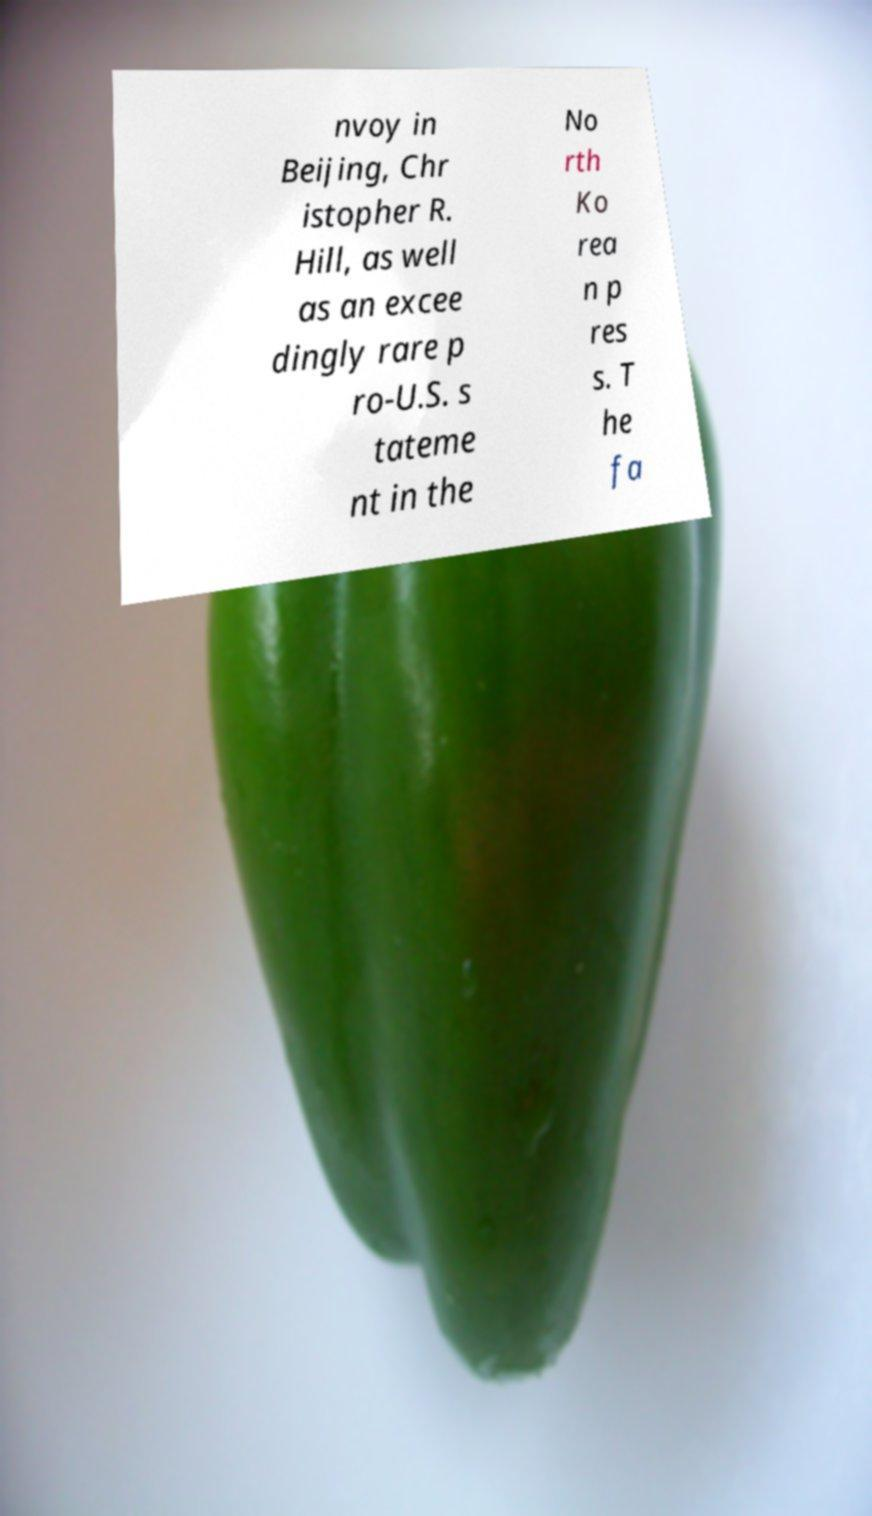Could you extract and type out the text from this image? nvoy in Beijing, Chr istopher R. Hill, as well as an excee dingly rare p ro-U.S. s tateme nt in the No rth Ko rea n p res s. T he fa 